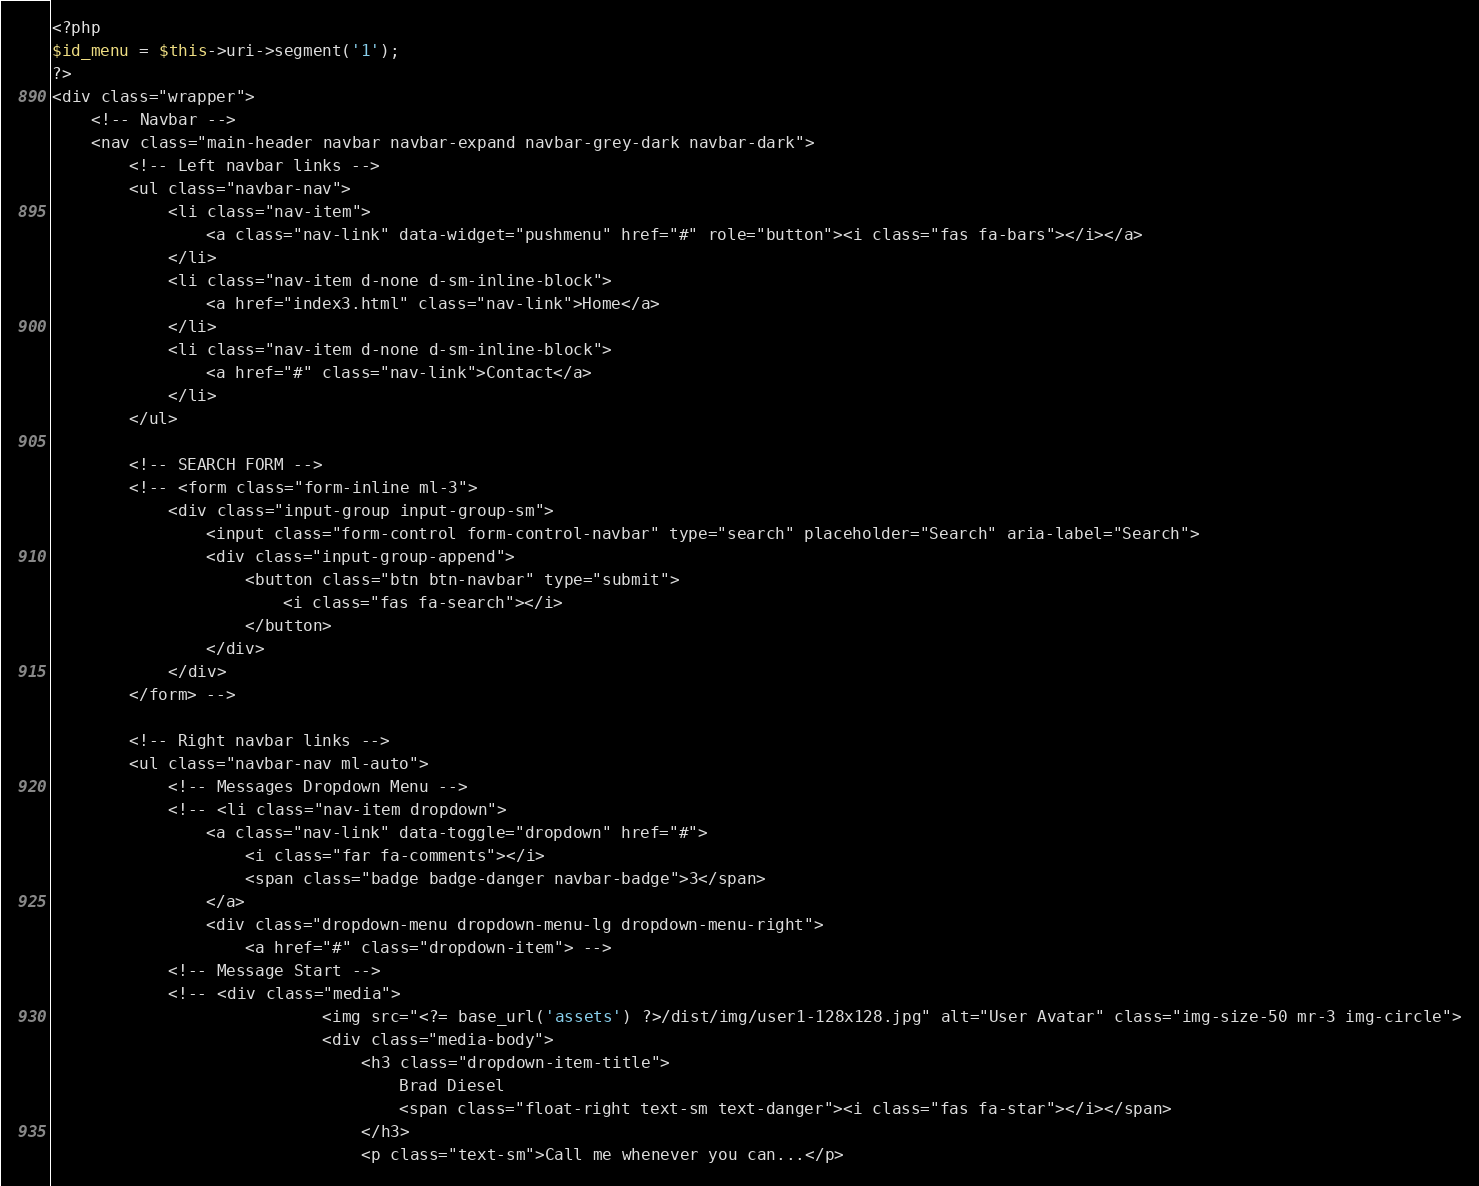<code> <loc_0><loc_0><loc_500><loc_500><_PHP_><?php
$id_menu = $this->uri->segment('1');
?>
<div class="wrapper">
    <!-- Navbar -->
    <nav class="main-header navbar navbar-expand navbar-grey-dark navbar-dark">
        <!-- Left navbar links -->
        <ul class="navbar-nav">
            <li class="nav-item">
                <a class="nav-link" data-widget="pushmenu" href="#" role="button"><i class="fas fa-bars"></i></a>
            </li>
            <li class="nav-item d-none d-sm-inline-block">
                <a href="index3.html" class="nav-link">Home</a>
            </li>
            <li class="nav-item d-none d-sm-inline-block">
                <a href="#" class="nav-link">Contact</a>
            </li>
        </ul>

        <!-- SEARCH FORM -->
        <!-- <form class="form-inline ml-3">
            <div class="input-group input-group-sm">
                <input class="form-control form-control-navbar" type="search" placeholder="Search" aria-label="Search">
                <div class="input-group-append">
                    <button class="btn btn-navbar" type="submit">
                        <i class="fas fa-search"></i>
                    </button>
                </div>
            </div>
        </form> -->

        <!-- Right navbar links -->
        <ul class="navbar-nav ml-auto">
            <!-- Messages Dropdown Menu -->
            <!-- <li class="nav-item dropdown">
                <a class="nav-link" data-toggle="dropdown" href="#">
                    <i class="far fa-comments"></i>
                    <span class="badge badge-danger navbar-badge">3</span>
                </a>
                <div class="dropdown-menu dropdown-menu-lg dropdown-menu-right">
                    <a href="#" class="dropdown-item"> -->
            <!-- Message Start -->
            <!-- <div class="media">
                            <img src="<?= base_url('assets') ?>/dist/img/user1-128x128.jpg" alt="User Avatar" class="img-size-50 mr-3 img-circle">
                            <div class="media-body">
                                <h3 class="dropdown-item-title">
                                    Brad Diesel
                                    <span class="float-right text-sm text-danger"><i class="fas fa-star"></i></span>
                                </h3>
                                <p class="text-sm">Call me whenever you can...</p></code> 